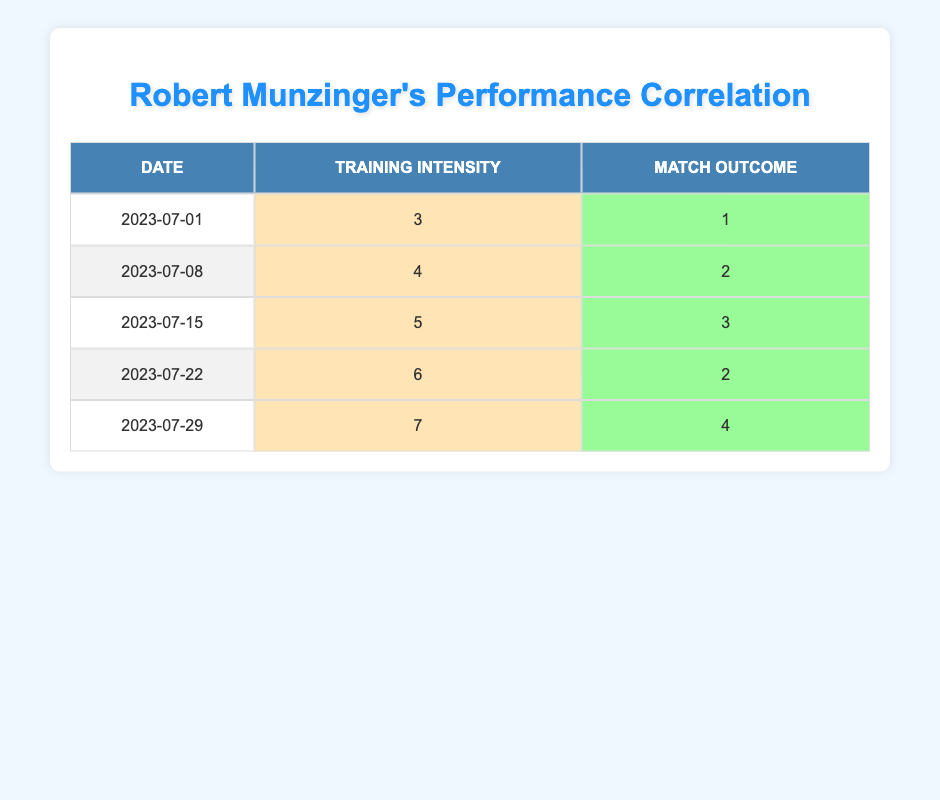What was Robert Munzinger's match outcome after a training intensity of 6? Looking at the row where the training intensity is 6, the match outcome is listed as 2.
Answer: 2 What is the training intensity associated with the match outcome of 4? In the row where the match outcome is 4, the corresponding training intensity is 7.
Answer: 7 What is the average match outcome across all the matches listed? The match outcomes are 1, 2, 3, 2, and 4. Adding them gives 1 + 2 + 3 + 2 + 4 = 12. There are 5 data points, so the average is 12/5 = 2.4.
Answer: 2.4 Was there a training intensity of 5 associated with a match outcome higher than 2? Yes, the match outcome for a training intensity of 5 is 3, which is higher than 2.
Answer: Yes What is the highest match outcome in the dataset? The match outcomes are 1, 2, 3, 2, and 4. The highest among these is 4.
Answer: 4 If the training intensity increased by 1 from 4 to 5, how much did the match outcome increase? The match outcome at training intensity 4 is 2, and at intensity 5, it is 3. The increase is 3 - 2 = 1.
Answer: 1 Which match had the lowest training intensity and what was the outcome? The match with the lowest training intensity is on 2023-07-01 with a training intensity of 3, and the match outcome is 1.
Answer: 1 What are the training intensities for matches with outcomes of 2? The matches with outcomes of 2 are on 2023-07-08 and 2023-07-22, with training intensities of 4 and 6, respectively.
Answer: 4 and 6 How many matches had a training intensity of 7? There is only one match with a training intensity of 7, which is on 2023-07-29.
Answer: 1 